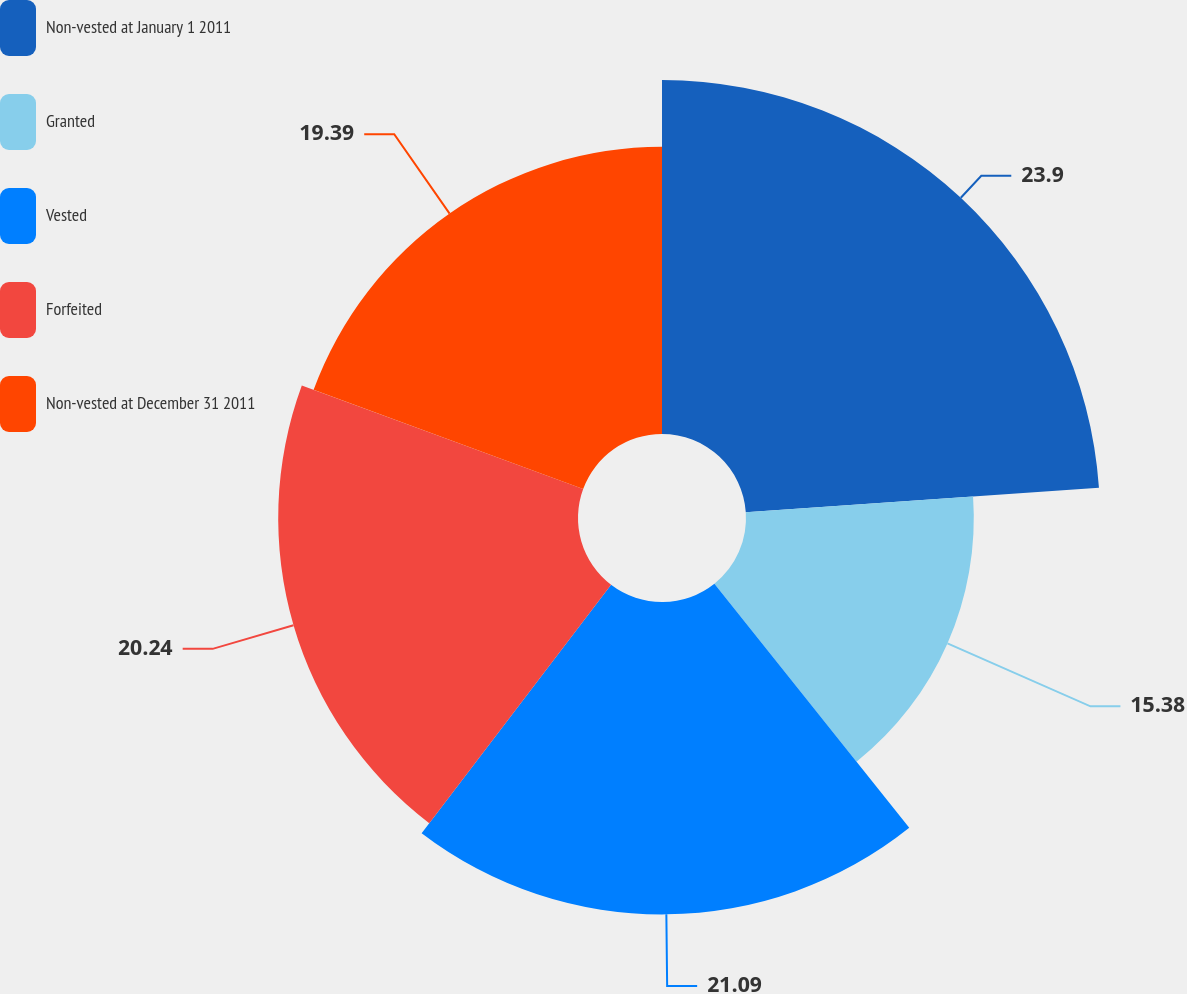Convert chart. <chart><loc_0><loc_0><loc_500><loc_500><pie_chart><fcel>Non-vested at January 1 2011<fcel>Granted<fcel>Vested<fcel>Forfeited<fcel>Non-vested at December 31 2011<nl><fcel>23.9%<fcel>15.38%<fcel>21.09%<fcel>20.24%<fcel>19.39%<nl></chart> 